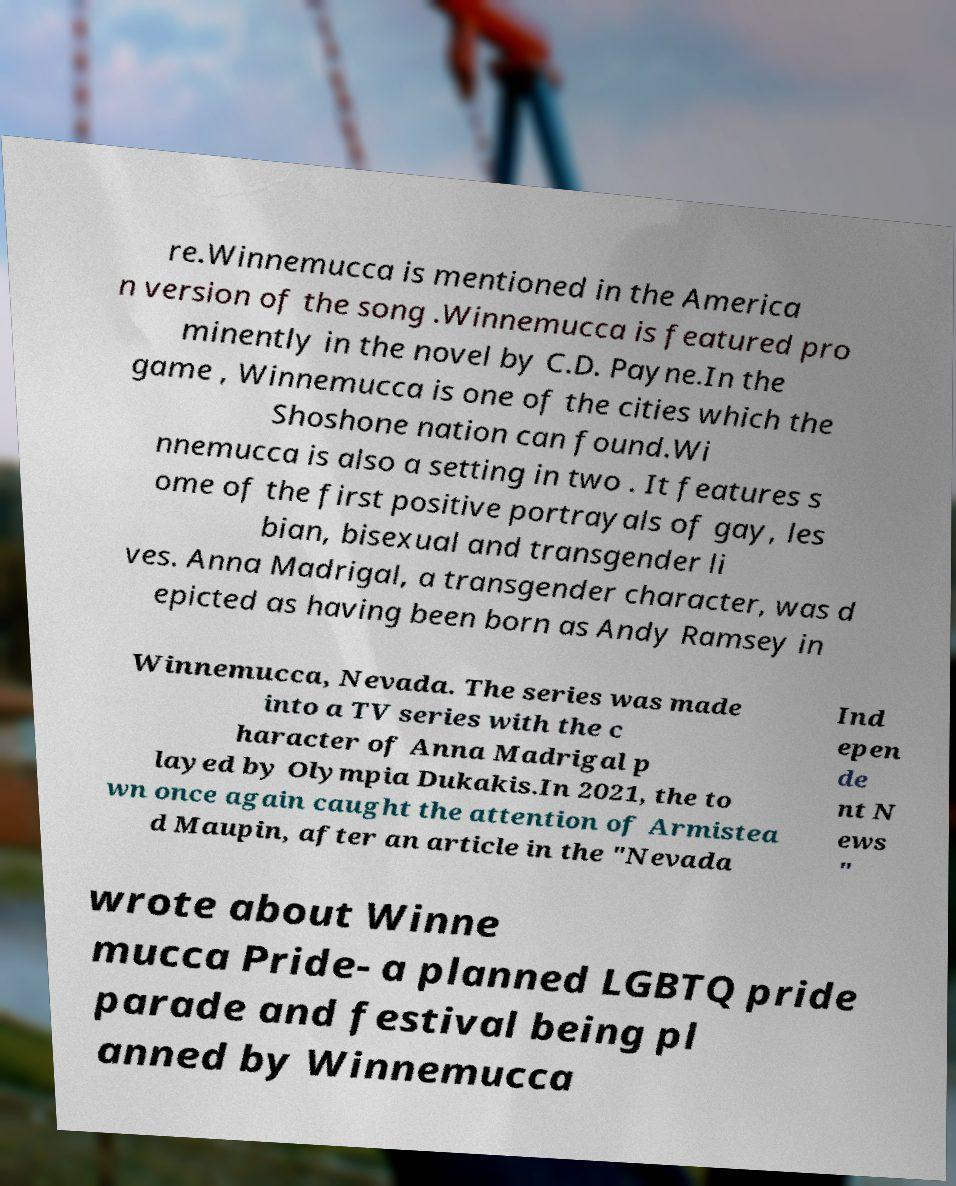For documentation purposes, I need the text within this image transcribed. Could you provide that? re.Winnemucca is mentioned in the America n version of the song .Winnemucca is featured pro minently in the novel by C.D. Payne.In the game , Winnemucca is one of the cities which the Shoshone nation can found.Wi nnemucca is also a setting in two . It features s ome of the first positive portrayals of gay, les bian, bisexual and transgender li ves. Anna Madrigal, a transgender character, was d epicted as having been born as Andy Ramsey in Winnemucca, Nevada. The series was made into a TV series with the c haracter of Anna Madrigal p layed by Olympia Dukakis.In 2021, the to wn once again caught the attention of Armistea d Maupin, after an article in the "Nevada Ind epen de nt N ews " wrote about Winne mucca Pride- a planned LGBTQ pride parade and festival being pl anned by Winnemucca 